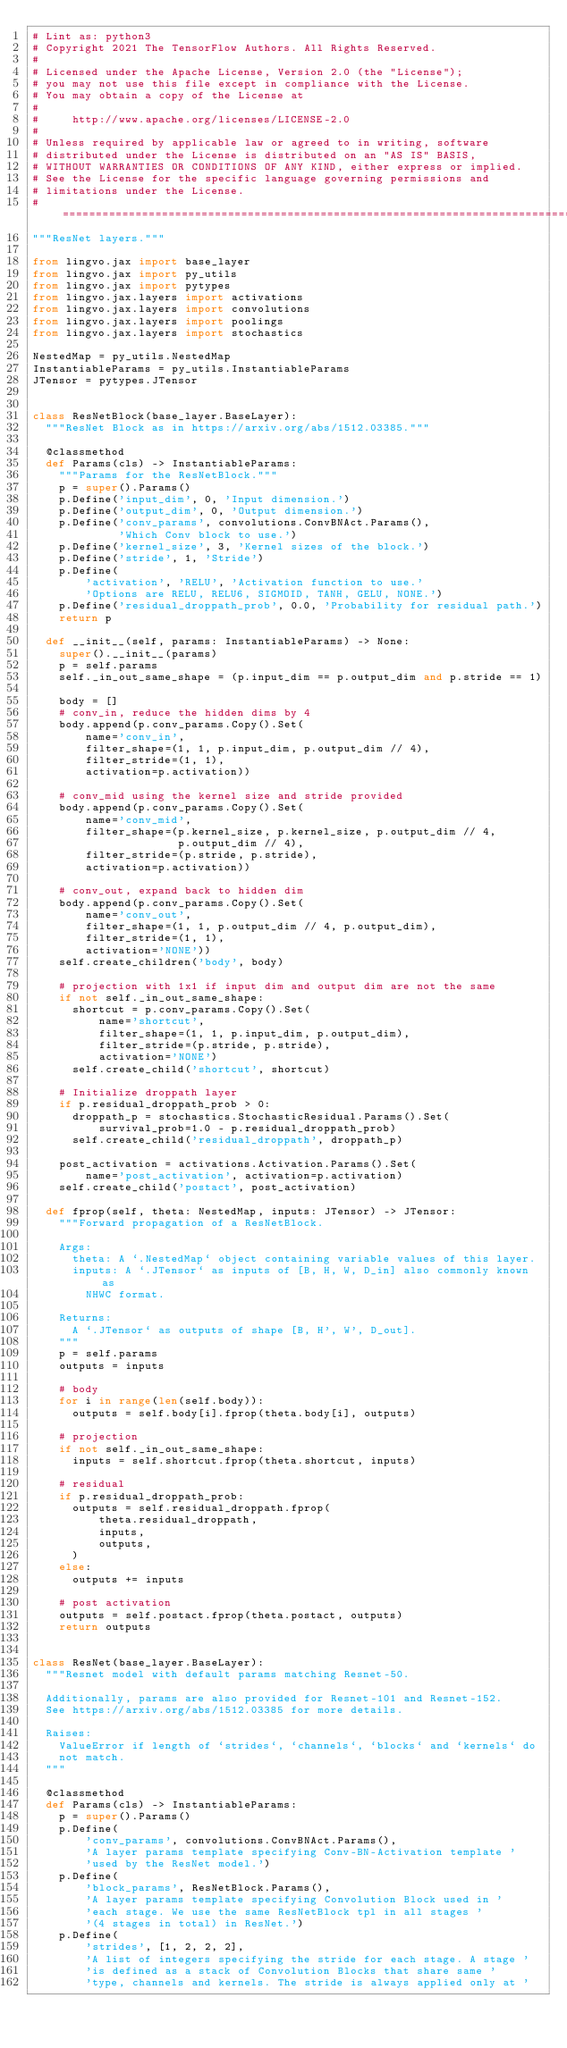<code> <loc_0><loc_0><loc_500><loc_500><_Python_># Lint as: python3
# Copyright 2021 The TensorFlow Authors. All Rights Reserved.
#
# Licensed under the Apache License, Version 2.0 (the "License");
# you may not use this file except in compliance with the License.
# You may obtain a copy of the License at
#
#     http://www.apache.org/licenses/LICENSE-2.0
#
# Unless required by applicable law or agreed to in writing, software
# distributed under the License is distributed on an "AS IS" BASIS,
# WITHOUT WARRANTIES OR CONDITIONS OF ANY KIND, either express or implied.
# See the License for the specific language governing permissions and
# limitations under the License.
# ==============================================================================
"""ResNet layers."""

from lingvo.jax import base_layer
from lingvo.jax import py_utils
from lingvo.jax import pytypes
from lingvo.jax.layers import activations
from lingvo.jax.layers import convolutions
from lingvo.jax.layers import poolings
from lingvo.jax.layers import stochastics

NestedMap = py_utils.NestedMap
InstantiableParams = py_utils.InstantiableParams
JTensor = pytypes.JTensor


class ResNetBlock(base_layer.BaseLayer):
  """ResNet Block as in https://arxiv.org/abs/1512.03385."""

  @classmethod
  def Params(cls) -> InstantiableParams:
    """Params for the ResNetBlock."""
    p = super().Params()
    p.Define('input_dim', 0, 'Input dimension.')
    p.Define('output_dim', 0, 'Output dimension.')
    p.Define('conv_params', convolutions.ConvBNAct.Params(),
             'Which Conv block to use.')
    p.Define('kernel_size', 3, 'Kernel sizes of the block.')
    p.Define('stride', 1, 'Stride')
    p.Define(
        'activation', 'RELU', 'Activation function to use.'
        'Options are RELU, RELU6, SIGMOID, TANH, GELU, NONE.')
    p.Define('residual_droppath_prob', 0.0, 'Probability for residual path.')
    return p

  def __init__(self, params: InstantiableParams) -> None:
    super().__init__(params)
    p = self.params
    self._in_out_same_shape = (p.input_dim == p.output_dim and p.stride == 1)

    body = []
    # conv_in, reduce the hidden dims by 4
    body.append(p.conv_params.Copy().Set(
        name='conv_in',
        filter_shape=(1, 1, p.input_dim, p.output_dim // 4),
        filter_stride=(1, 1),
        activation=p.activation))

    # conv_mid using the kernel size and stride provided
    body.append(p.conv_params.Copy().Set(
        name='conv_mid',
        filter_shape=(p.kernel_size, p.kernel_size, p.output_dim // 4,
                      p.output_dim // 4),
        filter_stride=(p.stride, p.stride),
        activation=p.activation))

    # conv_out, expand back to hidden dim
    body.append(p.conv_params.Copy().Set(
        name='conv_out',
        filter_shape=(1, 1, p.output_dim // 4, p.output_dim),
        filter_stride=(1, 1),
        activation='NONE'))
    self.create_children('body', body)

    # projection with 1x1 if input dim and output dim are not the same
    if not self._in_out_same_shape:
      shortcut = p.conv_params.Copy().Set(
          name='shortcut',
          filter_shape=(1, 1, p.input_dim, p.output_dim),
          filter_stride=(p.stride, p.stride),
          activation='NONE')
      self.create_child('shortcut', shortcut)

    # Initialize droppath layer
    if p.residual_droppath_prob > 0:
      droppath_p = stochastics.StochasticResidual.Params().Set(
          survival_prob=1.0 - p.residual_droppath_prob)
      self.create_child('residual_droppath', droppath_p)

    post_activation = activations.Activation.Params().Set(
        name='post_activation', activation=p.activation)
    self.create_child('postact', post_activation)

  def fprop(self, theta: NestedMap, inputs: JTensor) -> JTensor:
    """Forward propagation of a ResNetBlock.

    Args:
      theta: A `.NestedMap` object containing variable values of this layer.
      inputs: A `.JTensor` as inputs of [B, H, W, D_in] also commonly known as
        NHWC format.

    Returns:
      A `.JTensor` as outputs of shape [B, H', W', D_out].
    """
    p = self.params
    outputs = inputs

    # body
    for i in range(len(self.body)):
      outputs = self.body[i].fprop(theta.body[i], outputs)

    # projection
    if not self._in_out_same_shape:
      inputs = self.shortcut.fprop(theta.shortcut, inputs)

    # residual
    if p.residual_droppath_prob:
      outputs = self.residual_droppath.fprop(
          theta.residual_droppath,
          inputs,
          outputs,
      )
    else:
      outputs += inputs

    # post activation
    outputs = self.postact.fprop(theta.postact, outputs)
    return outputs


class ResNet(base_layer.BaseLayer):
  """Resnet model with default params matching Resnet-50.

  Additionally, params are also provided for Resnet-101 and Resnet-152.
  See https://arxiv.org/abs/1512.03385 for more details.

  Raises:
    ValueError if length of `strides`, `channels`, `blocks` and `kernels` do
    not match.
  """

  @classmethod
  def Params(cls) -> InstantiableParams:
    p = super().Params()
    p.Define(
        'conv_params', convolutions.ConvBNAct.Params(),
        'A layer params template specifying Conv-BN-Activation template '
        'used by the ResNet model.')
    p.Define(
        'block_params', ResNetBlock.Params(),
        'A layer params template specifying Convolution Block used in '
        'each stage. We use the same ResNetBlock tpl in all stages '
        '(4 stages in total) in ResNet.')
    p.Define(
        'strides', [1, 2, 2, 2],
        'A list of integers specifying the stride for each stage. A stage '
        'is defined as a stack of Convolution Blocks that share same '
        'type, channels and kernels. The stride is always applied only at '</code> 